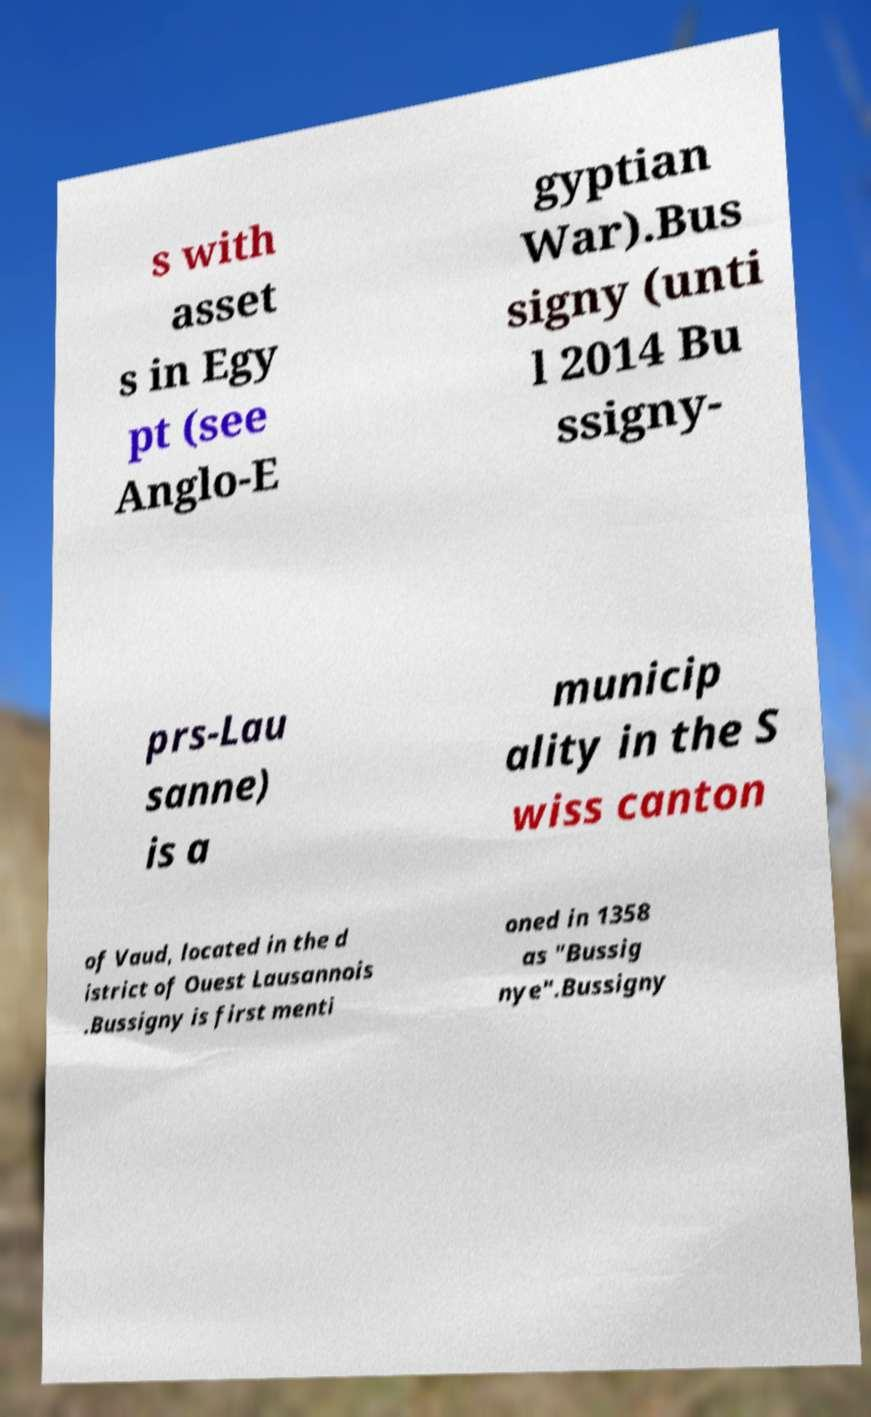What messages or text are displayed in this image? I need them in a readable, typed format. s with asset s in Egy pt (see Anglo-E gyptian War).Bus signy (unti l 2014 Bu ssigny- prs-Lau sanne) is a municip ality in the S wiss canton of Vaud, located in the d istrict of Ouest Lausannois .Bussigny is first menti oned in 1358 as "Bussig nye".Bussigny 